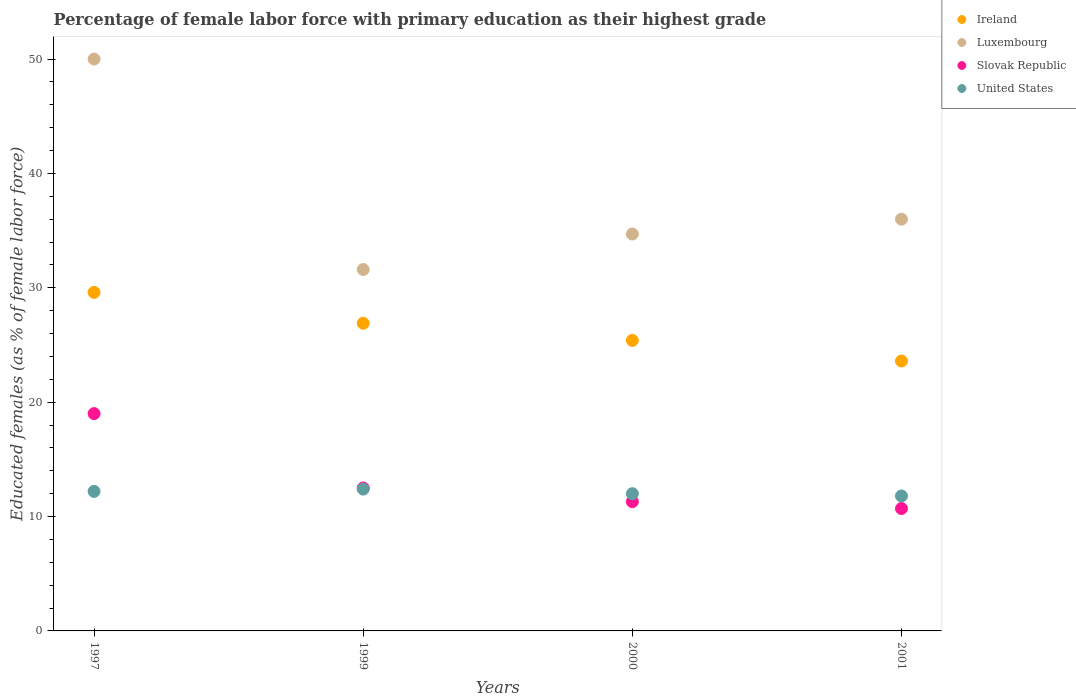Is the number of dotlines equal to the number of legend labels?
Keep it short and to the point. Yes. What is the percentage of female labor force with primary education in Luxembourg in 2001?
Provide a succinct answer. 36. Across all years, what is the minimum percentage of female labor force with primary education in United States?
Your answer should be very brief. 11.8. In which year was the percentage of female labor force with primary education in Ireland maximum?
Make the answer very short. 1997. In which year was the percentage of female labor force with primary education in United States minimum?
Your answer should be very brief. 2001. What is the total percentage of female labor force with primary education in Luxembourg in the graph?
Your answer should be very brief. 152.3. What is the difference between the percentage of female labor force with primary education in Ireland in 1997 and that in 2000?
Your answer should be very brief. 4.2. What is the difference between the percentage of female labor force with primary education in United States in 1997 and the percentage of female labor force with primary education in Slovak Republic in 2000?
Your answer should be compact. 0.9. What is the average percentage of female labor force with primary education in Ireland per year?
Offer a very short reply. 26.38. In the year 1999, what is the difference between the percentage of female labor force with primary education in United States and percentage of female labor force with primary education in Ireland?
Keep it short and to the point. -14.5. In how many years, is the percentage of female labor force with primary education in Slovak Republic greater than 28 %?
Make the answer very short. 0. What is the ratio of the percentage of female labor force with primary education in United States in 1997 to that in 1999?
Ensure brevity in your answer.  0.98. What is the difference between the highest and the second highest percentage of female labor force with primary education in Ireland?
Your answer should be compact. 2.7. Is the sum of the percentage of female labor force with primary education in Ireland in 1997 and 2000 greater than the maximum percentage of female labor force with primary education in Luxembourg across all years?
Your answer should be very brief. Yes. Does the percentage of female labor force with primary education in United States monotonically increase over the years?
Your answer should be very brief. No. Is the percentage of female labor force with primary education in Luxembourg strictly greater than the percentage of female labor force with primary education in Slovak Republic over the years?
Keep it short and to the point. Yes. Is the percentage of female labor force with primary education in Luxembourg strictly less than the percentage of female labor force with primary education in Ireland over the years?
Ensure brevity in your answer.  No. Where does the legend appear in the graph?
Give a very brief answer. Top right. How are the legend labels stacked?
Offer a very short reply. Vertical. What is the title of the graph?
Keep it short and to the point. Percentage of female labor force with primary education as their highest grade. What is the label or title of the Y-axis?
Your answer should be compact. Educated females (as % of female labor force). What is the Educated females (as % of female labor force) of Ireland in 1997?
Your answer should be compact. 29.6. What is the Educated females (as % of female labor force) in Luxembourg in 1997?
Make the answer very short. 50. What is the Educated females (as % of female labor force) of Slovak Republic in 1997?
Provide a succinct answer. 19. What is the Educated females (as % of female labor force) in United States in 1997?
Ensure brevity in your answer.  12.2. What is the Educated females (as % of female labor force) in Ireland in 1999?
Ensure brevity in your answer.  26.9. What is the Educated females (as % of female labor force) of Luxembourg in 1999?
Provide a short and direct response. 31.6. What is the Educated females (as % of female labor force) of United States in 1999?
Provide a short and direct response. 12.4. What is the Educated females (as % of female labor force) in Ireland in 2000?
Offer a terse response. 25.4. What is the Educated females (as % of female labor force) in Luxembourg in 2000?
Keep it short and to the point. 34.7. What is the Educated females (as % of female labor force) of Slovak Republic in 2000?
Your answer should be very brief. 11.3. What is the Educated females (as % of female labor force) of Ireland in 2001?
Make the answer very short. 23.6. What is the Educated females (as % of female labor force) of Luxembourg in 2001?
Give a very brief answer. 36. What is the Educated females (as % of female labor force) of Slovak Republic in 2001?
Keep it short and to the point. 10.7. What is the Educated females (as % of female labor force) in United States in 2001?
Your answer should be compact. 11.8. Across all years, what is the maximum Educated females (as % of female labor force) in Ireland?
Offer a very short reply. 29.6. Across all years, what is the maximum Educated females (as % of female labor force) in Luxembourg?
Your answer should be very brief. 50. Across all years, what is the maximum Educated females (as % of female labor force) in Slovak Republic?
Keep it short and to the point. 19. Across all years, what is the maximum Educated females (as % of female labor force) of United States?
Your response must be concise. 12.4. Across all years, what is the minimum Educated females (as % of female labor force) of Ireland?
Your response must be concise. 23.6. Across all years, what is the minimum Educated females (as % of female labor force) of Luxembourg?
Make the answer very short. 31.6. Across all years, what is the minimum Educated females (as % of female labor force) of Slovak Republic?
Offer a very short reply. 10.7. Across all years, what is the minimum Educated females (as % of female labor force) of United States?
Offer a terse response. 11.8. What is the total Educated females (as % of female labor force) of Ireland in the graph?
Keep it short and to the point. 105.5. What is the total Educated females (as % of female labor force) of Luxembourg in the graph?
Make the answer very short. 152.3. What is the total Educated females (as % of female labor force) of Slovak Republic in the graph?
Provide a succinct answer. 53.5. What is the total Educated females (as % of female labor force) of United States in the graph?
Your response must be concise. 48.4. What is the difference between the Educated females (as % of female labor force) of Ireland in 1997 and that in 1999?
Keep it short and to the point. 2.7. What is the difference between the Educated females (as % of female labor force) of Luxembourg in 1997 and that in 1999?
Keep it short and to the point. 18.4. What is the difference between the Educated females (as % of female labor force) of United States in 1997 and that in 1999?
Keep it short and to the point. -0.2. What is the difference between the Educated females (as % of female labor force) of Ireland in 1997 and that in 2000?
Your answer should be very brief. 4.2. What is the difference between the Educated females (as % of female labor force) in Luxembourg in 1997 and that in 2000?
Your response must be concise. 15.3. What is the difference between the Educated females (as % of female labor force) of Luxembourg in 1997 and that in 2001?
Provide a short and direct response. 14. What is the difference between the Educated females (as % of female labor force) in Slovak Republic in 1997 and that in 2001?
Provide a succinct answer. 8.3. What is the difference between the Educated females (as % of female labor force) of Ireland in 1999 and that in 2000?
Your answer should be compact. 1.5. What is the difference between the Educated females (as % of female labor force) of United States in 1999 and that in 2000?
Provide a short and direct response. 0.4. What is the difference between the Educated females (as % of female labor force) of Ireland in 1999 and that in 2001?
Give a very brief answer. 3.3. What is the difference between the Educated females (as % of female labor force) of Luxembourg in 1999 and that in 2001?
Make the answer very short. -4.4. What is the difference between the Educated females (as % of female labor force) in Slovak Republic in 1999 and that in 2001?
Your answer should be very brief. 1.8. What is the difference between the Educated females (as % of female labor force) of United States in 1999 and that in 2001?
Provide a short and direct response. 0.6. What is the difference between the Educated females (as % of female labor force) in Ireland in 2000 and that in 2001?
Offer a terse response. 1.8. What is the difference between the Educated females (as % of female labor force) in Slovak Republic in 2000 and that in 2001?
Provide a succinct answer. 0.6. What is the difference between the Educated females (as % of female labor force) of United States in 2000 and that in 2001?
Offer a terse response. 0.2. What is the difference between the Educated females (as % of female labor force) of Ireland in 1997 and the Educated females (as % of female labor force) of Luxembourg in 1999?
Provide a short and direct response. -2. What is the difference between the Educated females (as % of female labor force) of Ireland in 1997 and the Educated females (as % of female labor force) of Slovak Republic in 1999?
Your answer should be very brief. 17.1. What is the difference between the Educated females (as % of female labor force) in Ireland in 1997 and the Educated females (as % of female labor force) in United States in 1999?
Keep it short and to the point. 17.2. What is the difference between the Educated females (as % of female labor force) in Luxembourg in 1997 and the Educated females (as % of female labor force) in Slovak Republic in 1999?
Keep it short and to the point. 37.5. What is the difference between the Educated females (as % of female labor force) of Luxembourg in 1997 and the Educated females (as % of female labor force) of United States in 1999?
Offer a very short reply. 37.6. What is the difference between the Educated females (as % of female labor force) of Slovak Republic in 1997 and the Educated females (as % of female labor force) of United States in 1999?
Offer a very short reply. 6.6. What is the difference between the Educated females (as % of female labor force) in Ireland in 1997 and the Educated females (as % of female labor force) in Slovak Republic in 2000?
Give a very brief answer. 18.3. What is the difference between the Educated females (as % of female labor force) in Ireland in 1997 and the Educated females (as % of female labor force) in United States in 2000?
Provide a short and direct response. 17.6. What is the difference between the Educated females (as % of female labor force) of Luxembourg in 1997 and the Educated females (as % of female labor force) of Slovak Republic in 2000?
Your answer should be very brief. 38.7. What is the difference between the Educated females (as % of female labor force) in Luxembourg in 1997 and the Educated females (as % of female labor force) in United States in 2000?
Keep it short and to the point. 38. What is the difference between the Educated females (as % of female labor force) in Slovak Republic in 1997 and the Educated females (as % of female labor force) in United States in 2000?
Provide a succinct answer. 7. What is the difference between the Educated females (as % of female labor force) of Ireland in 1997 and the Educated females (as % of female labor force) of Luxembourg in 2001?
Offer a very short reply. -6.4. What is the difference between the Educated females (as % of female labor force) of Ireland in 1997 and the Educated females (as % of female labor force) of Slovak Republic in 2001?
Ensure brevity in your answer.  18.9. What is the difference between the Educated females (as % of female labor force) of Luxembourg in 1997 and the Educated females (as % of female labor force) of Slovak Republic in 2001?
Provide a succinct answer. 39.3. What is the difference between the Educated females (as % of female labor force) in Luxembourg in 1997 and the Educated females (as % of female labor force) in United States in 2001?
Keep it short and to the point. 38.2. What is the difference between the Educated females (as % of female labor force) in Slovak Republic in 1997 and the Educated females (as % of female labor force) in United States in 2001?
Your answer should be very brief. 7.2. What is the difference between the Educated females (as % of female labor force) of Ireland in 1999 and the Educated females (as % of female labor force) of Luxembourg in 2000?
Your answer should be very brief. -7.8. What is the difference between the Educated females (as % of female labor force) of Ireland in 1999 and the Educated females (as % of female labor force) of Slovak Republic in 2000?
Provide a short and direct response. 15.6. What is the difference between the Educated females (as % of female labor force) of Ireland in 1999 and the Educated females (as % of female labor force) of United States in 2000?
Keep it short and to the point. 14.9. What is the difference between the Educated females (as % of female labor force) of Luxembourg in 1999 and the Educated females (as % of female labor force) of Slovak Republic in 2000?
Make the answer very short. 20.3. What is the difference between the Educated females (as % of female labor force) in Luxembourg in 1999 and the Educated females (as % of female labor force) in United States in 2000?
Provide a short and direct response. 19.6. What is the difference between the Educated females (as % of female labor force) of Slovak Republic in 1999 and the Educated females (as % of female labor force) of United States in 2000?
Keep it short and to the point. 0.5. What is the difference between the Educated females (as % of female labor force) in Ireland in 1999 and the Educated females (as % of female labor force) in Luxembourg in 2001?
Give a very brief answer. -9.1. What is the difference between the Educated females (as % of female labor force) in Ireland in 1999 and the Educated females (as % of female labor force) in Slovak Republic in 2001?
Provide a succinct answer. 16.2. What is the difference between the Educated females (as % of female labor force) of Ireland in 1999 and the Educated females (as % of female labor force) of United States in 2001?
Your response must be concise. 15.1. What is the difference between the Educated females (as % of female labor force) of Luxembourg in 1999 and the Educated females (as % of female labor force) of Slovak Republic in 2001?
Ensure brevity in your answer.  20.9. What is the difference between the Educated females (as % of female labor force) of Luxembourg in 1999 and the Educated females (as % of female labor force) of United States in 2001?
Provide a succinct answer. 19.8. What is the difference between the Educated females (as % of female labor force) of Slovak Republic in 1999 and the Educated females (as % of female labor force) of United States in 2001?
Offer a terse response. 0.7. What is the difference between the Educated females (as % of female labor force) in Ireland in 2000 and the Educated females (as % of female labor force) in Luxembourg in 2001?
Your answer should be very brief. -10.6. What is the difference between the Educated females (as % of female labor force) in Ireland in 2000 and the Educated females (as % of female labor force) in Slovak Republic in 2001?
Your answer should be compact. 14.7. What is the difference between the Educated females (as % of female labor force) of Ireland in 2000 and the Educated females (as % of female labor force) of United States in 2001?
Ensure brevity in your answer.  13.6. What is the difference between the Educated females (as % of female labor force) in Luxembourg in 2000 and the Educated females (as % of female labor force) in United States in 2001?
Ensure brevity in your answer.  22.9. What is the average Educated females (as % of female labor force) of Ireland per year?
Ensure brevity in your answer.  26.38. What is the average Educated females (as % of female labor force) of Luxembourg per year?
Your answer should be compact. 38.08. What is the average Educated females (as % of female labor force) of Slovak Republic per year?
Your response must be concise. 13.38. What is the average Educated females (as % of female labor force) of United States per year?
Provide a short and direct response. 12.1. In the year 1997, what is the difference between the Educated females (as % of female labor force) of Ireland and Educated females (as % of female labor force) of Luxembourg?
Your answer should be compact. -20.4. In the year 1997, what is the difference between the Educated females (as % of female labor force) of Ireland and Educated females (as % of female labor force) of Slovak Republic?
Offer a very short reply. 10.6. In the year 1997, what is the difference between the Educated females (as % of female labor force) of Luxembourg and Educated females (as % of female labor force) of Slovak Republic?
Your response must be concise. 31. In the year 1997, what is the difference between the Educated females (as % of female labor force) of Luxembourg and Educated females (as % of female labor force) of United States?
Provide a short and direct response. 37.8. In the year 1997, what is the difference between the Educated females (as % of female labor force) in Slovak Republic and Educated females (as % of female labor force) in United States?
Your answer should be very brief. 6.8. In the year 1999, what is the difference between the Educated females (as % of female labor force) of Ireland and Educated females (as % of female labor force) of Luxembourg?
Provide a succinct answer. -4.7. In the year 1999, what is the difference between the Educated females (as % of female labor force) of Ireland and Educated females (as % of female labor force) of Slovak Republic?
Ensure brevity in your answer.  14.4. In the year 1999, what is the difference between the Educated females (as % of female labor force) in Luxembourg and Educated females (as % of female labor force) in Slovak Republic?
Give a very brief answer. 19.1. In the year 1999, what is the difference between the Educated females (as % of female labor force) in Slovak Republic and Educated females (as % of female labor force) in United States?
Ensure brevity in your answer.  0.1. In the year 2000, what is the difference between the Educated females (as % of female labor force) in Ireland and Educated females (as % of female labor force) in Luxembourg?
Your answer should be very brief. -9.3. In the year 2000, what is the difference between the Educated females (as % of female labor force) of Luxembourg and Educated females (as % of female labor force) of Slovak Republic?
Provide a succinct answer. 23.4. In the year 2000, what is the difference between the Educated females (as % of female labor force) of Luxembourg and Educated females (as % of female labor force) of United States?
Give a very brief answer. 22.7. In the year 2000, what is the difference between the Educated females (as % of female labor force) in Slovak Republic and Educated females (as % of female labor force) in United States?
Offer a terse response. -0.7. In the year 2001, what is the difference between the Educated females (as % of female labor force) of Ireland and Educated females (as % of female labor force) of Slovak Republic?
Keep it short and to the point. 12.9. In the year 2001, what is the difference between the Educated females (as % of female labor force) in Luxembourg and Educated females (as % of female labor force) in Slovak Republic?
Provide a succinct answer. 25.3. In the year 2001, what is the difference between the Educated females (as % of female labor force) of Luxembourg and Educated females (as % of female labor force) of United States?
Make the answer very short. 24.2. What is the ratio of the Educated females (as % of female labor force) of Ireland in 1997 to that in 1999?
Offer a very short reply. 1.1. What is the ratio of the Educated females (as % of female labor force) of Luxembourg in 1997 to that in 1999?
Your response must be concise. 1.58. What is the ratio of the Educated females (as % of female labor force) in Slovak Republic in 1997 to that in 1999?
Your answer should be very brief. 1.52. What is the ratio of the Educated females (as % of female labor force) of United States in 1997 to that in 1999?
Ensure brevity in your answer.  0.98. What is the ratio of the Educated females (as % of female labor force) of Ireland in 1997 to that in 2000?
Give a very brief answer. 1.17. What is the ratio of the Educated females (as % of female labor force) of Luxembourg in 1997 to that in 2000?
Give a very brief answer. 1.44. What is the ratio of the Educated females (as % of female labor force) in Slovak Republic in 1997 to that in 2000?
Provide a short and direct response. 1.68. What is the ratio of the Educated females (as % of female labor force) of United States in 1997 to that in 2000?
Provide a short and direct response. 1.02. What is the ratio of the Educated females (as % of female labor force) in Ireland in 1997 to that in 2001?
Keep it short and to the point. 1.25. What is the ratio of the Educated females (as % of female labor force) in Luxembourg in 1997 to that in 2001?
Give a very brief answer. 1.39. What is the ratio of the Educated females (as % of female labor force) in Slovak Republic in 1997 to that in 2001?
Your response must be concise. 1.78. What is the ratio of the Educated females (as % of female labor force) of United States in 1997 to that in 2001?
Offer a terse response. 1.03. What is the ratio of the Educated females (as % of female labor force) in Ireland in 1999 to that in 2000?
Give a very brief answer. 1.06. What is the ratio of the Educated females (as % of female labor force) in Luxembourg in 1999 to that in 2000?
Offer a very short reply. 0.91. What is the ratio of the Educated females (as % of female labor force) in Slovak Republic in 1999 to that in 2000?
Provide a succinct answer. 1.11. What is the ratio of the Educated females (as % of female labor force) of United States in 1999 to that in 2000?
Give a very brief answer. 1.03. What is the ratio of the Educated females (as % of female labor force) of Ireland in 1999 to that in 2001?
Offer a very short reply. 1.14. What is the ratio of the Educated females (as % of female labor force) of Luxembourg in 1999 to that in 2001?
Make the answer very short. 0.88. What is the ratio of the Educated females (as % of female labor force) of Slovak Republic in 1999 to that in 2001?
Make the answer very short. 1.17. What is the ratio of the Educated females (as % of female labor force) of United States in 1999 to that in 2001?
Make the answer very short. 1.05. What is the ratio of the Educated females (as % of female labor force) in Ireland in 2000 to that in 2001?
Your answer should be compact. 1.08. What is the ratio of the Educated females (as % of female labor force) of Luxembourg in 2000 to that in 2001?
Your answer should be very brief. 0.96. What is the ratio of the Educated females (as % of female labor force) of Slovak Republic in 2000 to that in 2001?
Provide a succinct answer. 1.06. What is the ratio of the Educated females (as % of female labor force) of United States in 2000 to that in 2001?
Your answer should be very brief. 1.02. What is the difference between the highest and the second highest Educated females (as % of female labor force) in Ireland?
Give a very brief answer. 2.7. What is the difference between the highest and the lowest Educated females (as % of female labor force) of Slovak Republic?
Ensure brevity in your answer.  8.3. 